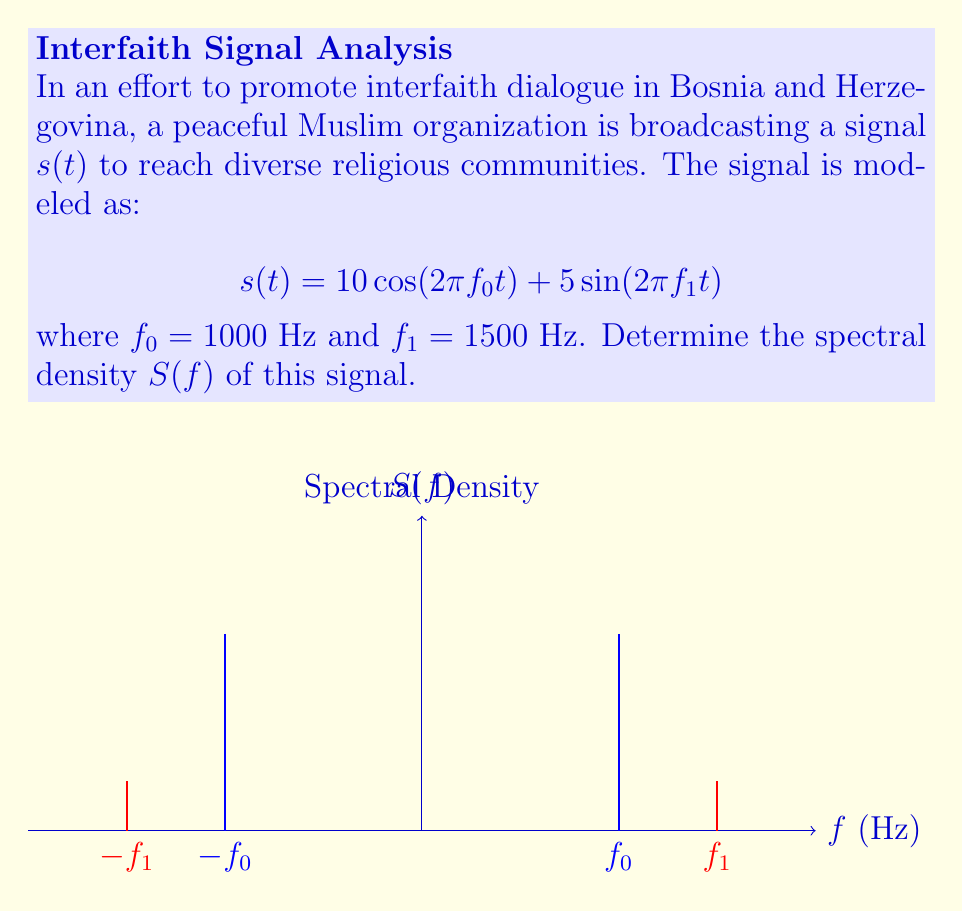Help me with this question. To find the spectral density of the signal, we follow these steps:

1) First, recall that the spectral density of a deterministic signal is given by the magnitude squared of its Fourier transform divided by the total time $T$. As $T \to \infty$, this becomes a series of delta functions.

2) The Fourier transform of $\cos(2\pi f_0 t)$ is:
   $$\frac{1}{2}[\delta(f-f_0) + \delta(f+f_0)]$$

3) The Fourier transform of $\sin(2\pi f_1 t)$ is:
   $$\frac{1}{2j}[\delta(f-f_1) - \delta(f+f_1)]$$

4) Therefore, the Fourier transform of $s(t)$ is:
   $$S(f) = 5[\delta(f-f_0) + \delta(f+f_0)] + \frac{5}{2j}[\delta(f-f_1) - \delta(f+f_1)]$$

5) The spectral density is the magnitude squared of this:
   $$S(f) = 25[\delta^2(f-f_0) + \delta^2(f+f_0)] + \frac{25}{4}[\delta^2(f-f_1) + \delta^2(f+f_1)]$$

6) Simplify using the property $\delta^2(x) = \infty \cdot \delta(x)$:
   $$S(f) = 25\infty[\delta(f-f_0) + \delta(f+f_0)] + \frac{25}{4}\infty[\delta(f-f_1) + \delta(f+f_1)]$$

This represents two pairs of impulses: one pair at $\pm f_0$ with strength $25\infty$, and another at $\pm f_1$ with strength $\frac{25}{4}\infty$.
Answer: $$S(f) = 25\infty[\delta(f\pm1000)] + \frac{25}{4}\infty[\delta(f\pm1500)]$$ 